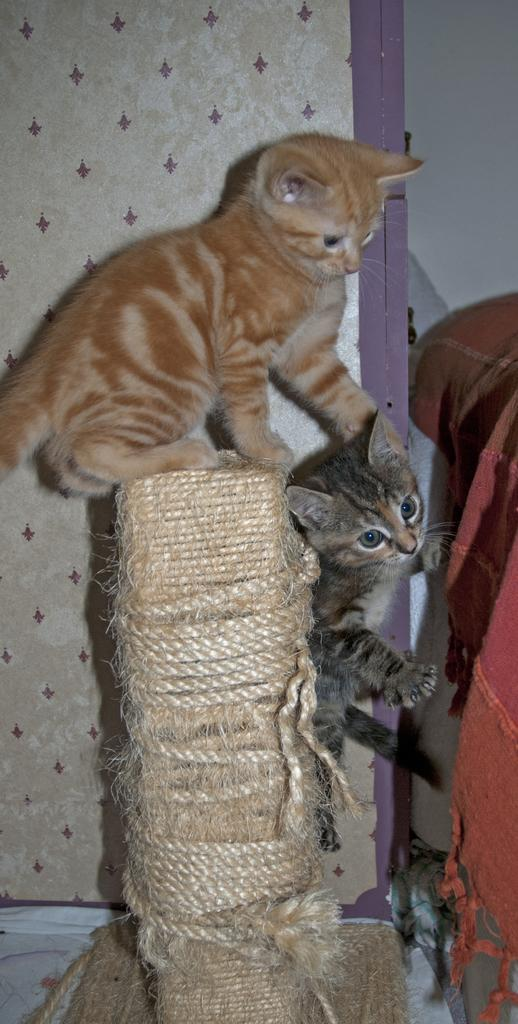How many cats are in the image? There are two cats in the image. What is one of the cats doing in the image? One cat is sitting on a wooden object coiled with rope. What can be seen in the background of the image? There is a wall visible in the background of the image. What type of fold can be seen in the image? There is no fold present in the image. What channel is the cat watching in the image? There is no television or channel visible in the image. 